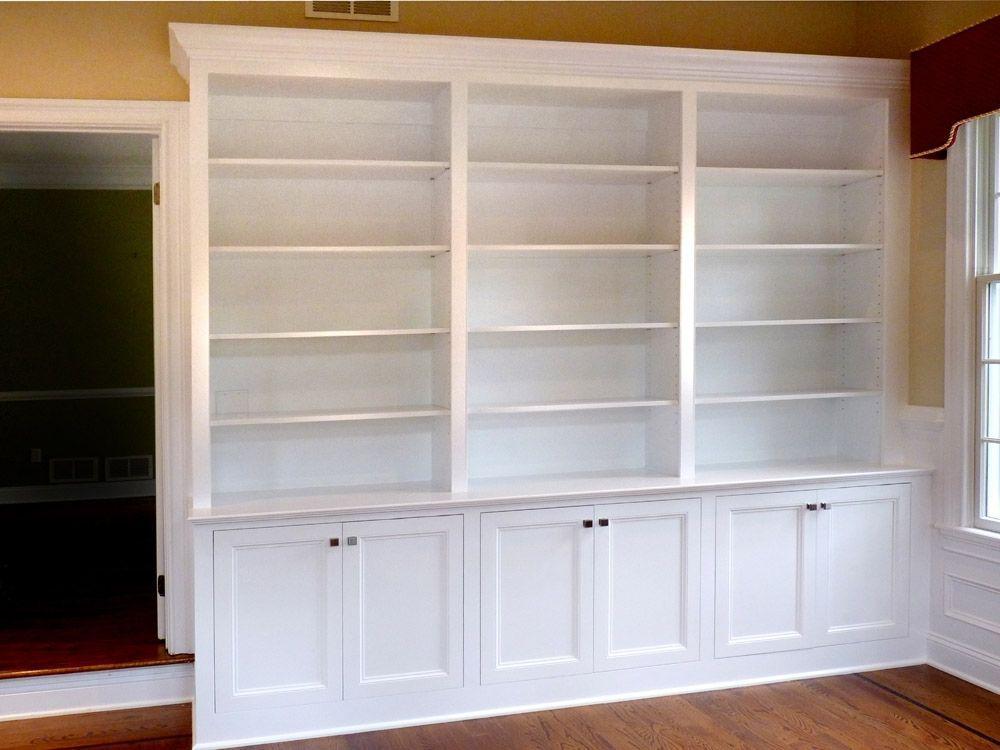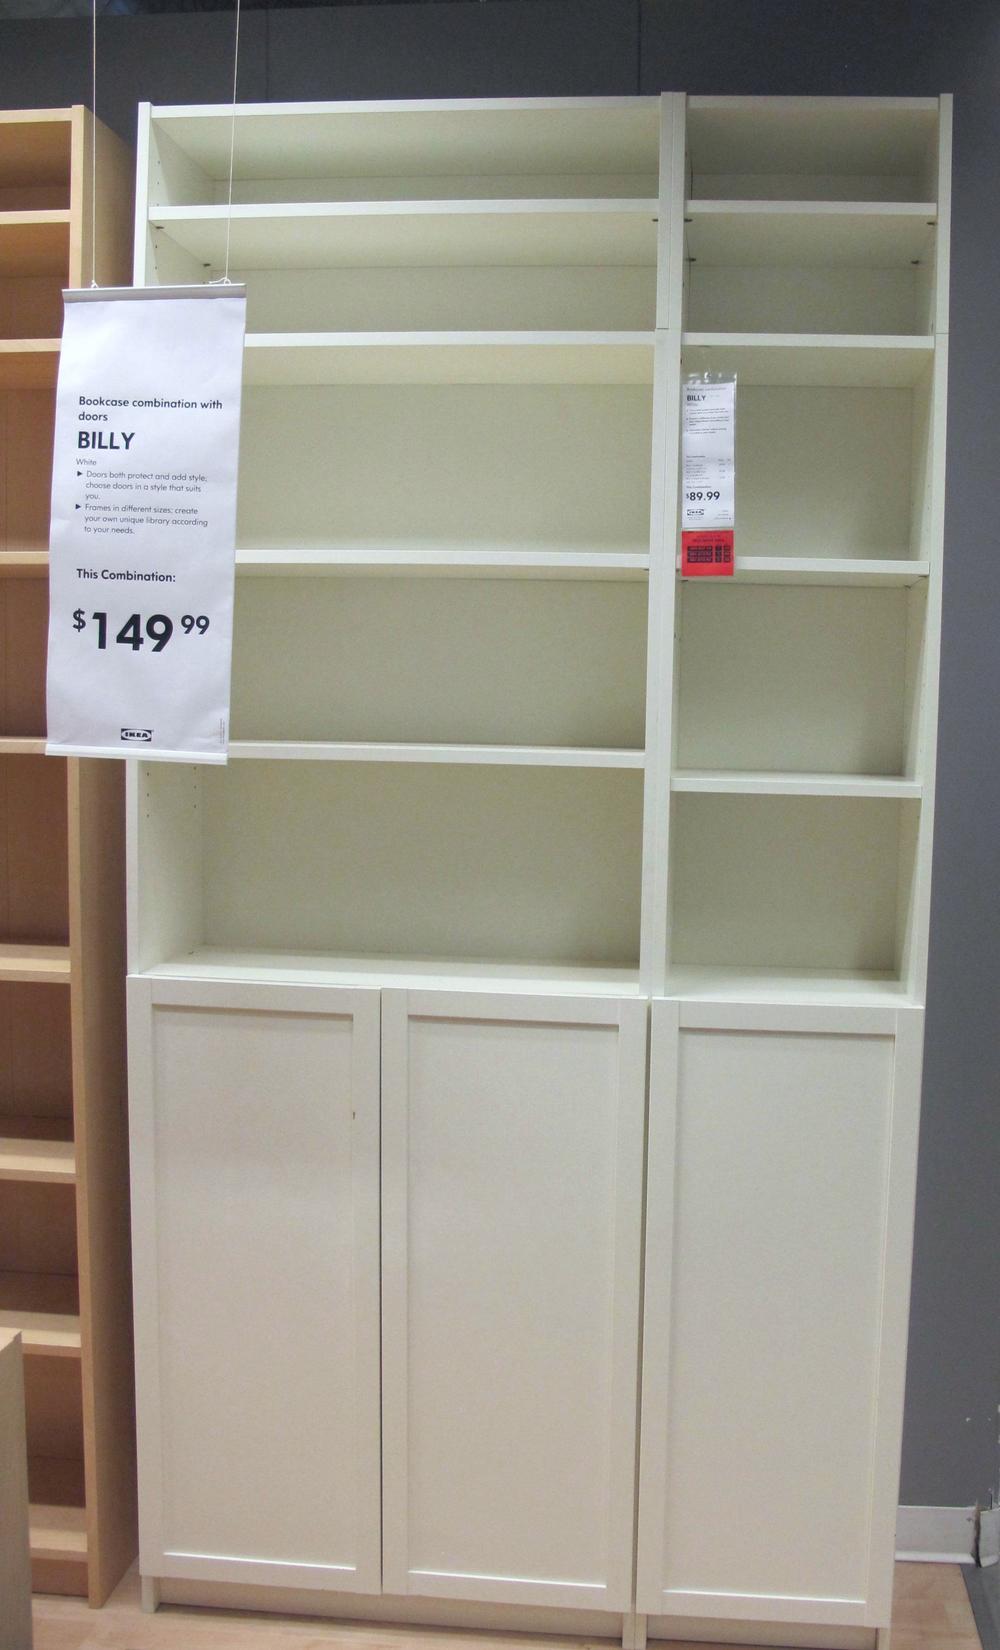The first image is the image on the left, the second image is the image on the right. For the images displayed, is the sentence "Each image includes an empty white storage unit that reaches toward the ceiling, and at least one image shows a storage unit on a light wood floor." factually correct? Answer yes or no. Yes. The first image is the image on the left, the second image is the image on the right. Considering the images on both sides, is "The shelving unit in the image on the right is empty." valid? Answer yes or no. Yes. 